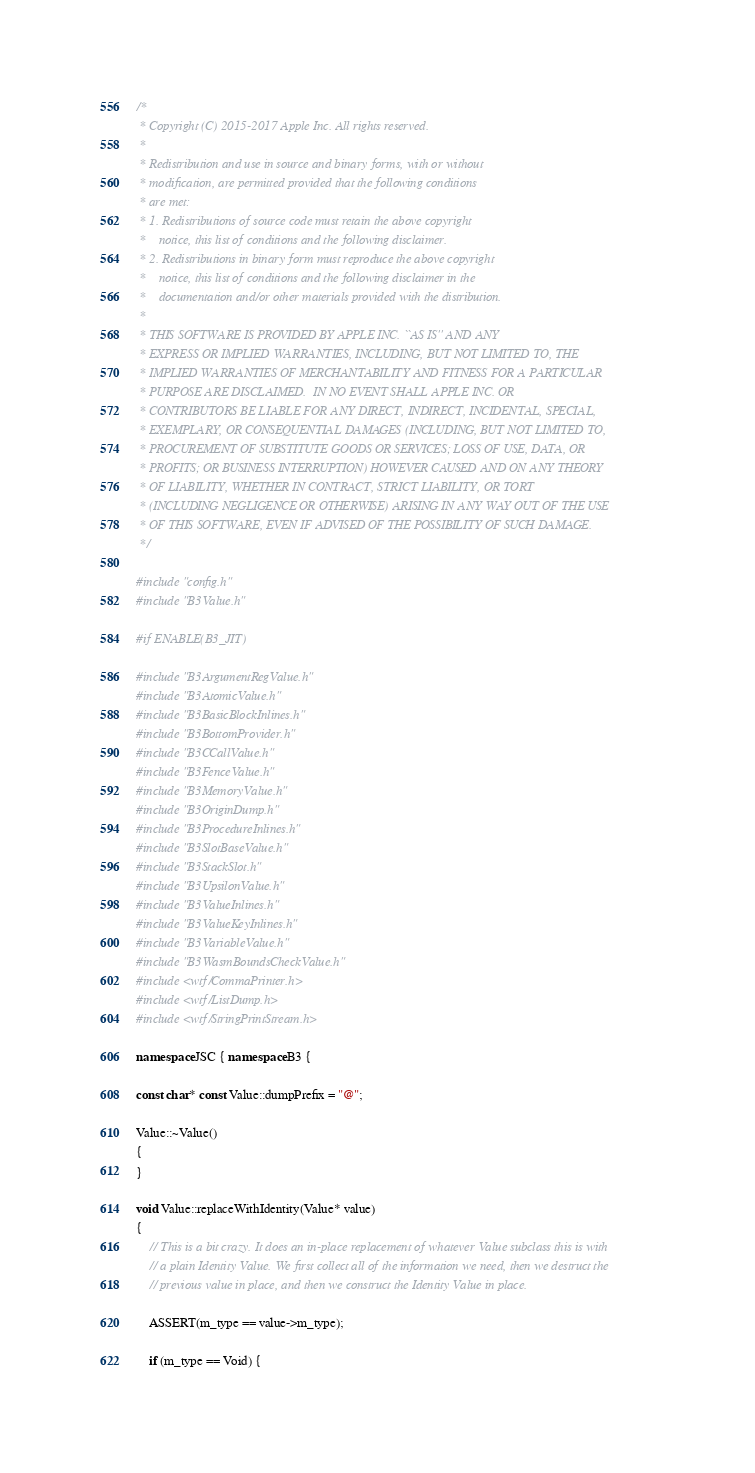Convert code to text. <code><loc_0><loc_0><loc_500><loc_500><_C++_>/*
 * Copyright (C) 2015-2017 Apple Inc. All rights reserved.
 *
 * Redistribution and use in source and binary forms, with or without
 * modification, are permitted provided that the following conditions
 * are met:
 * 1. Redistributions of source code must retain the above copyright
 *    notice, this list of conditions and the following disclaimer.
 * 2. Redistributions in binary form must reproduce the above copyright
 *    notice, this list of conditions and the following disclaimer in the
 *    documentation and/or other materials provided with the distribution.
 *
 * THIS SOFTWARE IS PROVIDED BY APPLE INC. ``AS IS'' AND ANY
 * EXPRESS OR IMPLIED WARRANTIES, INCLUDING, BUT NOT LIMITED TO, THE
 * IMPLIED WARRANTIES OF MERCHANTABILITY AND FITNESS FOR A PARTICULAR
 * PURPOSE ARE DISCLAIMED.  IN NO EVENT SHALL APPLE INC. OR
 * CONTRIBUTORS BE LIABLE FOR ANY DIRECT, INDIRECT, INCIDENTAL, SPECIAL,
 * EXEMPLARY, OR CONSEQUENTIAL DAMAGES (INCLUDING, BUT NOT LIMITED TO,
 * PROCUREMENT OF SUBSTITUTE GOODS OR SERVICES; LOSS OF USE, DATA, OR
 * PROFITS; OR BUSINESS INTERRUPTION) HOWEVER CAUSED AND ON ANY THEORY
 * OF LIABILITY, WHETHER IN CONTRACT, STRICT LIABILITY, OR TORT
 * (INCLUDING NEGLIGENCE OR OTHERWISE) ARISING IN ANY WAY OUT OF THE USE
 * OF THIS SOFTWARE, EVEN IF ADVISED OF THE POSSIBILITY OF SUCH DAMAGE. 
 */

#include "config.h"
#include "B3Value.h"

#if ENABLE(B3_JIT)

#include "B3ArgumentRegValue.h"
#include "B3AtomicValue.h"
#include "B3BasicBlockInlines.h"
#include "B3BottomProvider.h"
#include "B3CCallValue.h"
#include "B3FenceValue.h"
#include "B3MemoryValue.h"
#include "B3OriginDump.h"
#include "B3ProcedureInlines.h"
#include "B3SlotBaseValue.h"
#include "B3StackSlot.h"
#include "B3UpsilonValue.h"
#include "B3ValueInlines.h"
#include "B3ValueKeyInlines.h"
#include "B3VariableValue.h"
#include "B3WasmBoundsCheckValue.h"
#include <wtf/CommaPrinter.h>
#include <wtf/ListDump.h>
#include <wtf/StringPrintStream.h>

namespace JSC { namespace B3 {

const char* const Value::dumpPrefix = "@";

Value::~Value()
{
}

void Value::replaceWithIdentity(Value* value)
{
    // This is a bit crazy. It does an in-place replacement of whatever Value subclass this is with
    // a plain Identity Value. We first collect all of the information we need, then we destruct the
    // previous value in place, and then we construct the Identity Value in place.

    ASSERT(m_type == value->m_type);

    if (m_type == Void) {</code> 